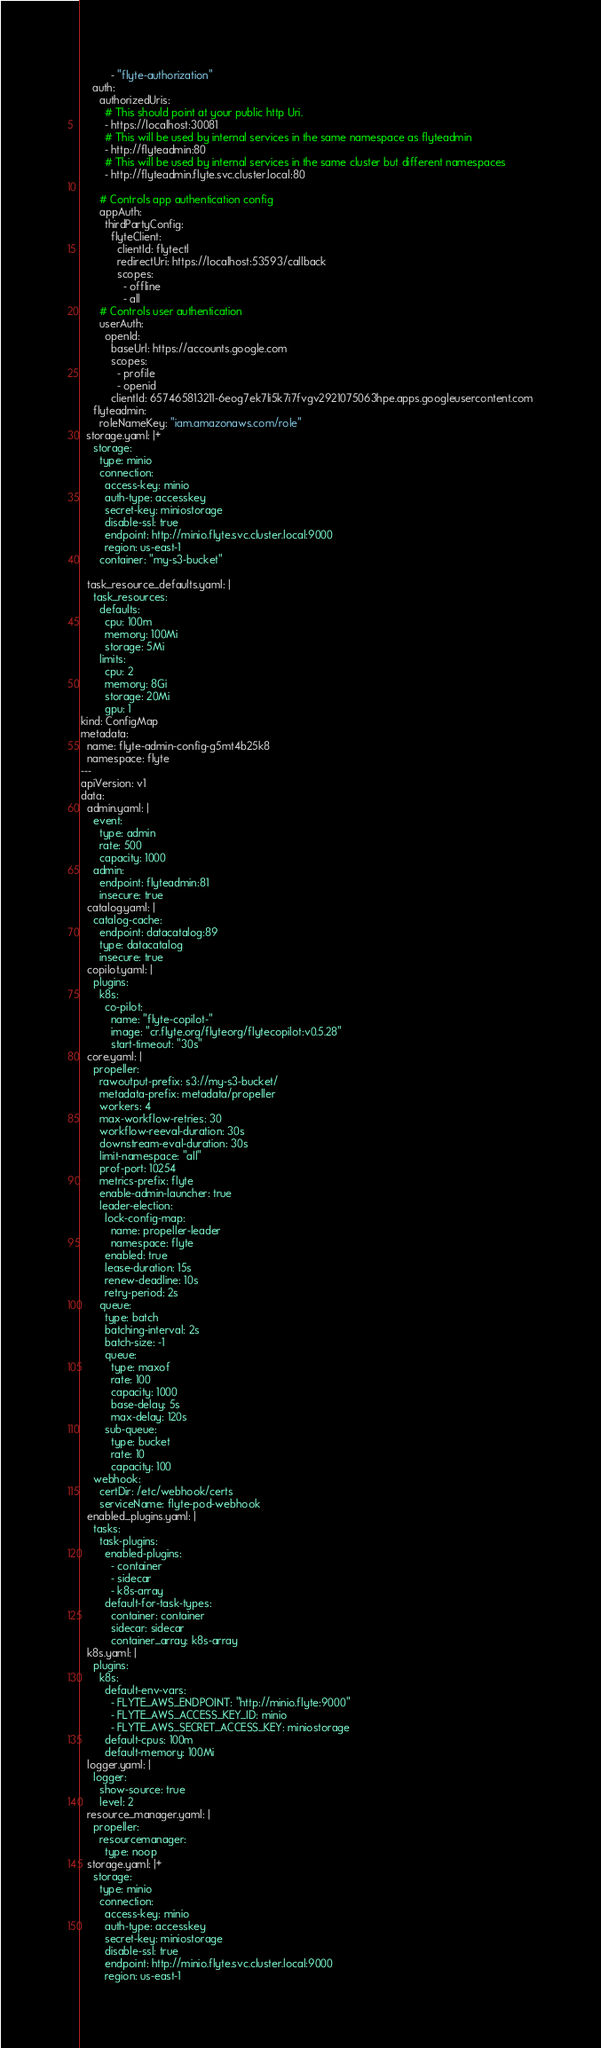<code> <loc_0><loc_0><loc_500><loc_500><_YAML_>          - "flyte-authorization"
    auth:
      authorizedUris:
        # This should point at your public http Uri.
        - https://localhost:30081
        # This will be used by internal services in the same namespace as flyteadmin
        - http://flyteadmin:80
        # This will be used by internal services in the same cluster but different namespaces
        - http://flyteadmin.flyte.svc.cluster.local:80

      # Controls app authentication config
      appAuth:
        thirdPartyConfig:
          flyteClient:
            clientId: flytectl
            redirectUri: https://localhost:53593/callback
            scopes:
              - offline
              - all
      # Controls user authentication
      userAuth:
        openId:
          baseUrl: https://accounts.google.com
          scopes:
            - profile
            - openid
          clientId: 657465813211-6eog7ek7li5k7i7fvgv2921075063hpe.apps.googleusercontent.com
    flyteadmin:
      roleNameKey: "iam.amazonaws.com/role"
  storage.yaml: |+
    storage:
      type: minio
      connection:
        access-key: minio
        auth-type: accesskey
        secret-key: miniostorage
        disable-ssl: true
        endpoint: http://minio.flyte.svc.cluster.local:9000
        region: us-east-1
      container: "my-s3-bucket"

  task_resource_defaults.yaml: |
    task_resources:
      defaults:
        cpu: 100m
        memory: 100Mi
        storage: 5Mi
      limits:
        cpu: 2
        memory: 8Gi
        storage: 20Mi
        gpu: 1
kind: ConfigMap
metadata:
  name: flyte-admin-config-g5mt4b25k8
  namespace: flyte
---
apiVersion: v1
data:
  admin.yaml: |
    event:
      type: admin
      rate: 500
      capacity: 1000
    admin:
      endpoint: flyteadmin:81
      insecure: true
  catalog.yaml: |
    catalog-cache:
      endpoint: datacatalog:89
      type: datacatalog
      insecure: true
  copilot.yaml: |
    plugins:
      k8s:
        co-pilot:
          name: "flyte-copilot-"
          image: "cr.flyte.org/flyteorg/flytecopilot:v0.5.28"
          start-timeout: "30s"
  core.yaml: |
    propeller:
      rawoutput-prefix: s3://my-s3-bucket/
      metadata-prefix: metadata/propeller
      workers: 4
      max-workflow-retries: 30
      workflow-reeval-duration: 30s
      downstream-eval-duration: 30s
      limit-namespace: "all"
      prof-port: 10254
      metrics-prefix: flyte
      enable-admin-launcher: true
      leader-election:
        lock-config-map:
          name: propeller-leader
          namespace: flyte
        enabled: true
        lease-duration: 15s
        renew-deadline: 10s
        retry-period: 2s
      queue:
        type: batch
        batching-interval: 2s
        batch-size: -1
        queue:
          type: maxof
          rate: 100
          capacity: 1000
          base-delay: 5s
          max-delay: 120s
        sub-queue:
          type: bucket
          rate: 10
          capacity: 100
    webhook:
      certDir: /etc/webhook/certs
      serviceName: flyte-pod-webhook
  enabled_plugins.yaml: |
    tasks:
      task-plugins:
        enabled-plugins:
          - container
          - sidecar
          - k8s-array
        default-for-task-types:
          container: container
          sidecar: sidecar
          container_array: k8s-array
  k8s.yaml: |
    plugins:
      k8s:
        default-env-vars:
          - FLYTE_AWS_ENDPOINT: "http://minio.flyte:9000"
          - FLYTE_AWS_ACCESS_KEY_ID: minio
          - FLYTE_AWS_SECRET_ACCESS_KEY: miniostorage
        default-cpus: 100m
        default-memory: 100Mi
  logger.yaml: |
    logger:
      show-source: true
      level: 2
  resource_manager.yaml: |
    propeller:
      resourcemanager:
        type: noop
  storage.yaml: |+
    storage:
      type: minio
      connection:
        access-key: minio
        auth-type: accesskey
        secret-key: miniostorage
        disable-ssl: true
        endpoint: http://minio.flyte.svc.cluster.local:9000
        region: us-east-1</code> 